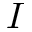Convert formula to latex. <formula><loc_0><loc_0><loc_500><loc_500>I</formula> 